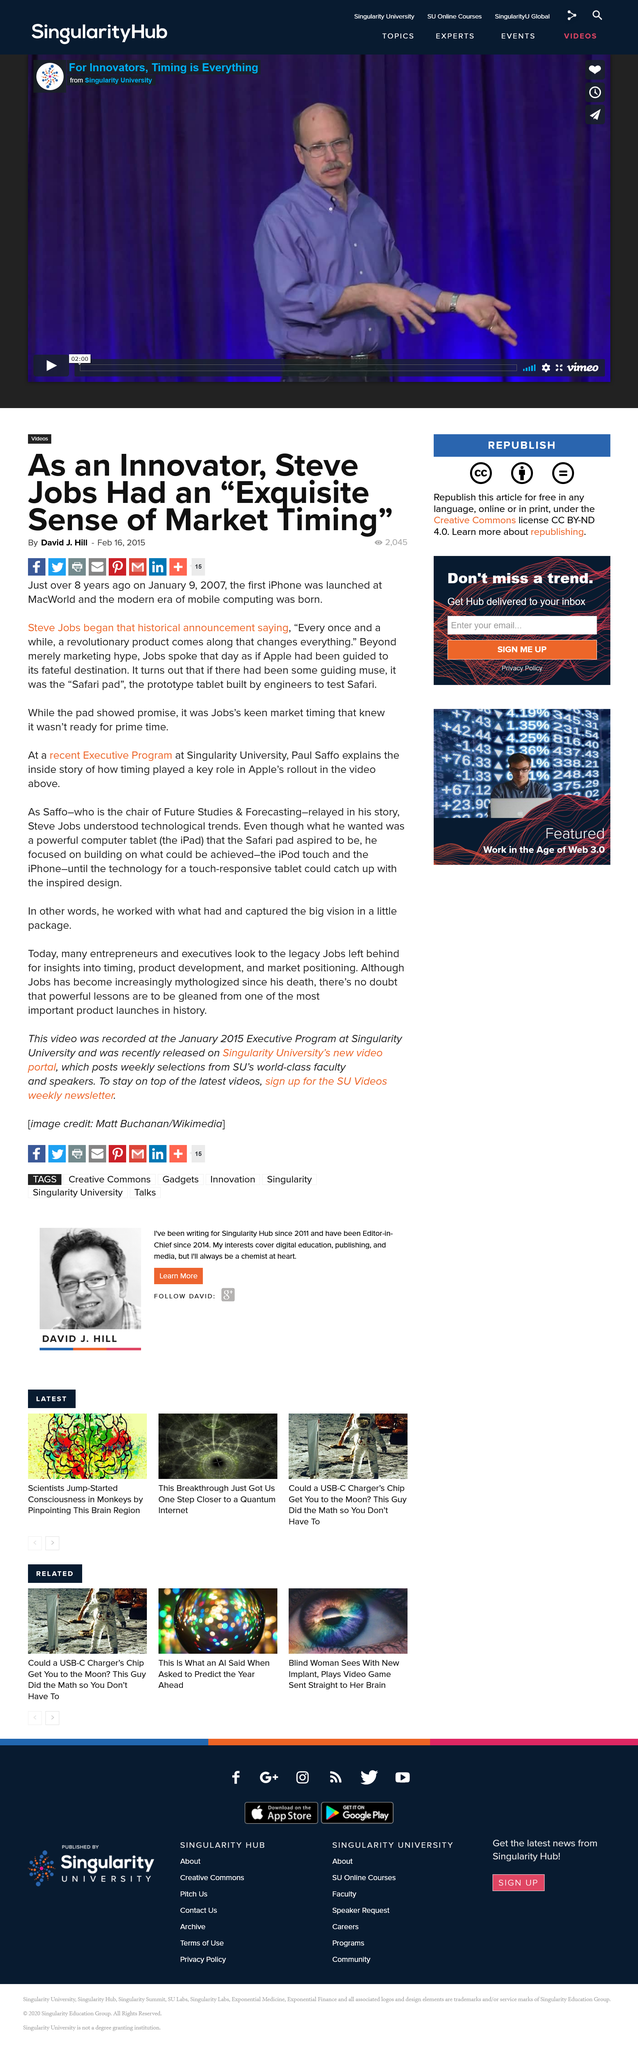Give some essential details in this illustration. The Executive Program took place at Singularity University. The first iPhone was launched on January 9, 2007. Apple's rollout was explained in the video above by Paul Saffo, who highlighted the importance of timing in the company's success. 